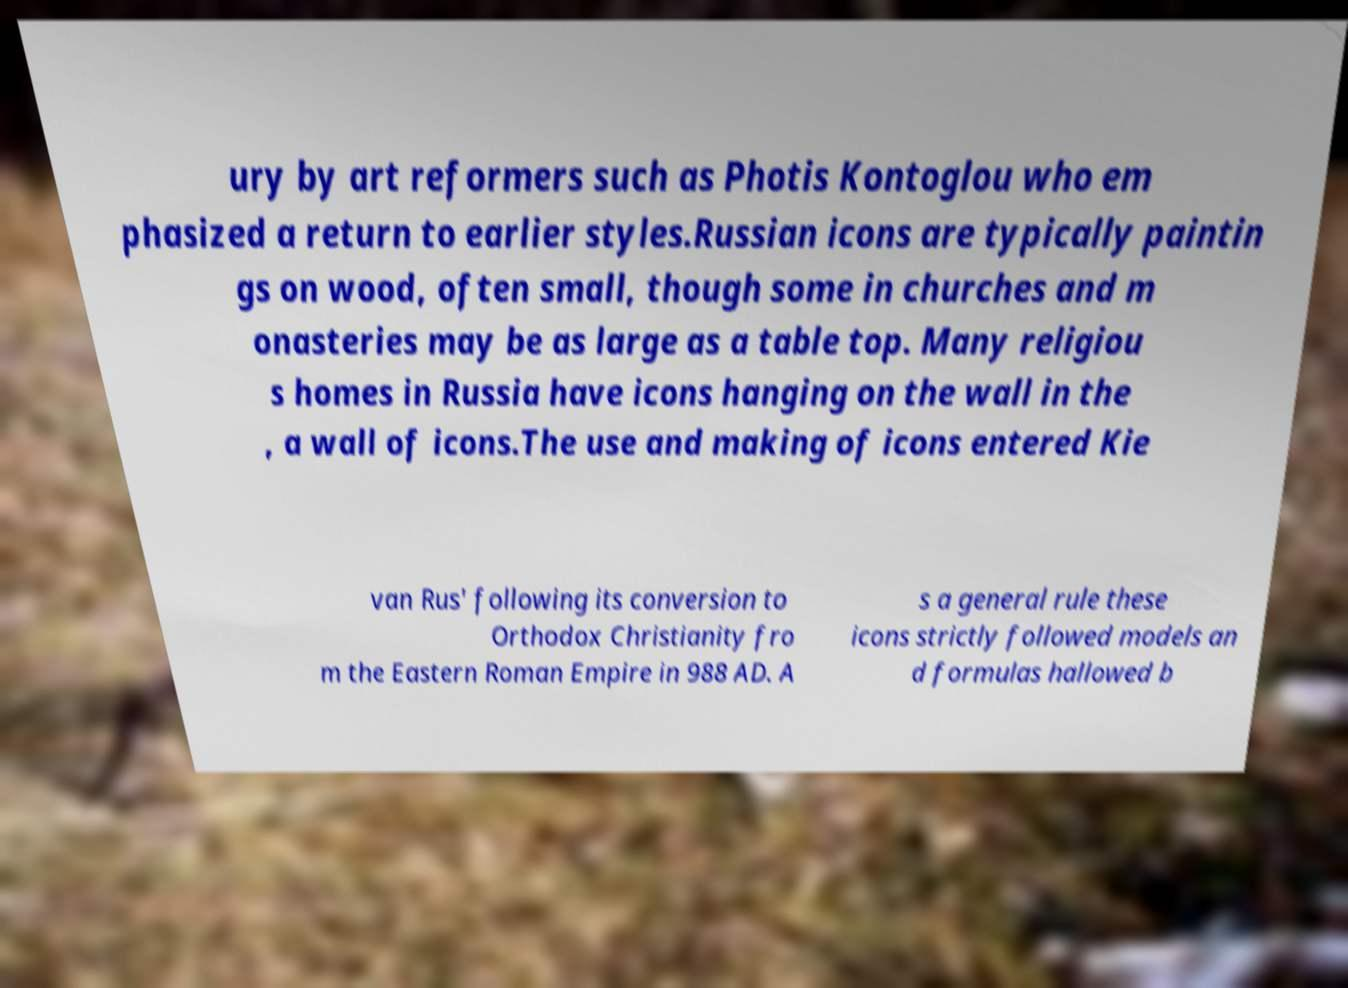There's text embedded in this image that I need extracted. Can you transcribe it verbatim? ury by art reformers such as Photis Kontoglou who em phasized a return to earlier styles.Russian icons are typically paintin gs on wood, often small, though some in churches and m onasteries may be as large as a table top. Many religiou s homes in Russia have icons hanging on the wall in the , a wall of icons.The use and making of icons entered Kie van Rus' following its conversion to Orthodox Christianity fro m the Eastern Roman Empire in 988 AD. A s a general rule these icons strictly followed models an d formulas hallowed b 